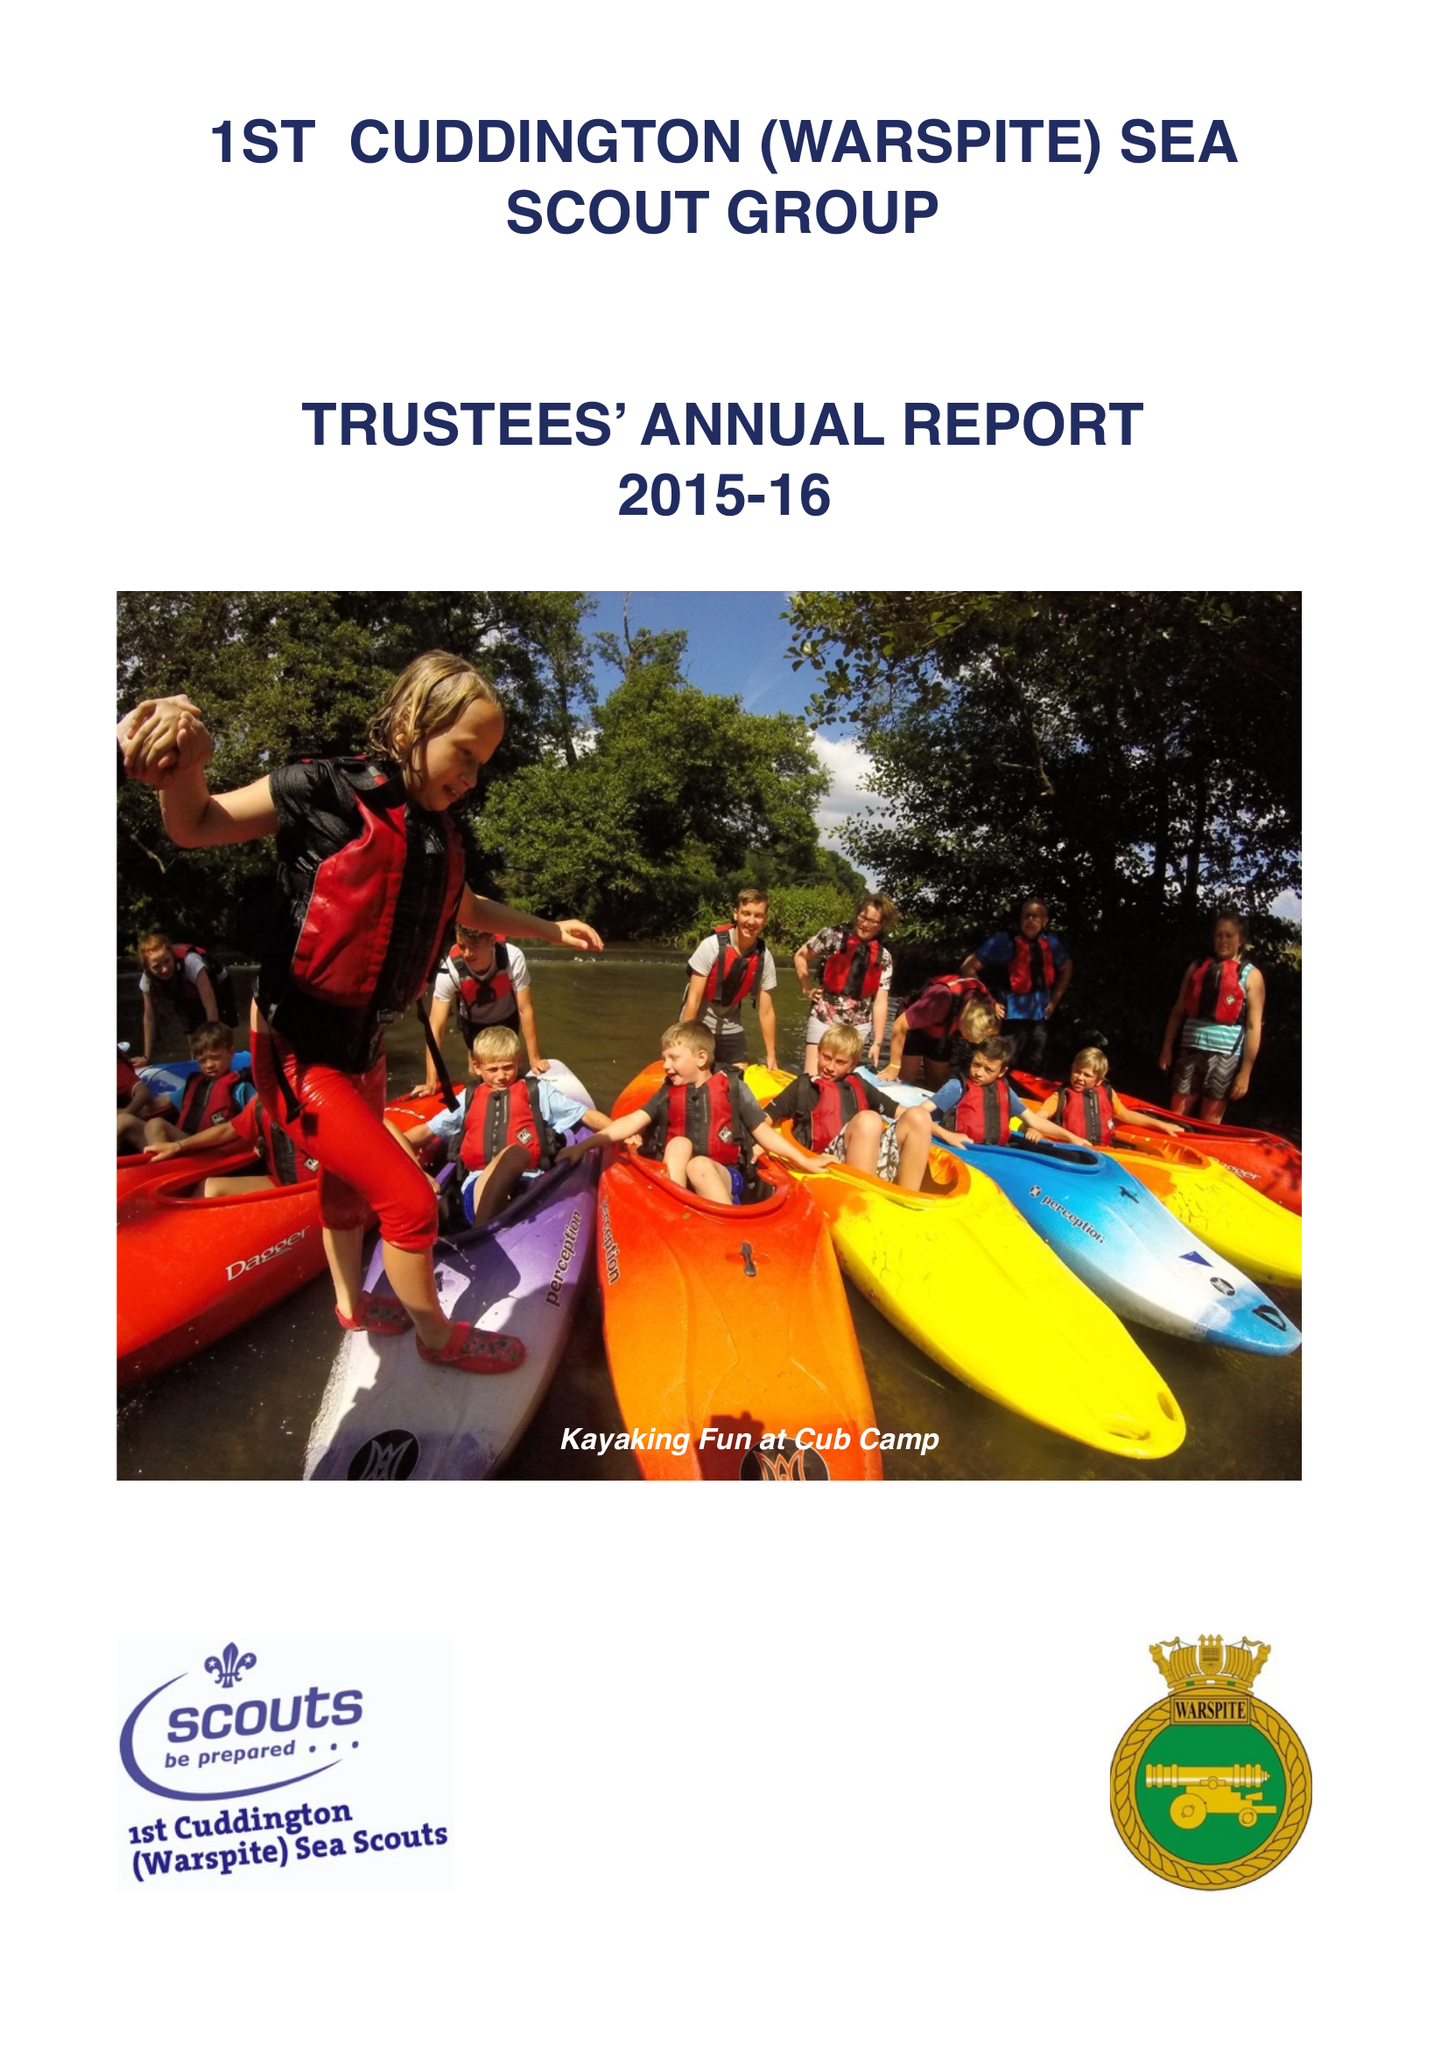What is the value for the report_date?
Answer the question using a single word or phrase. 2016-03-31 